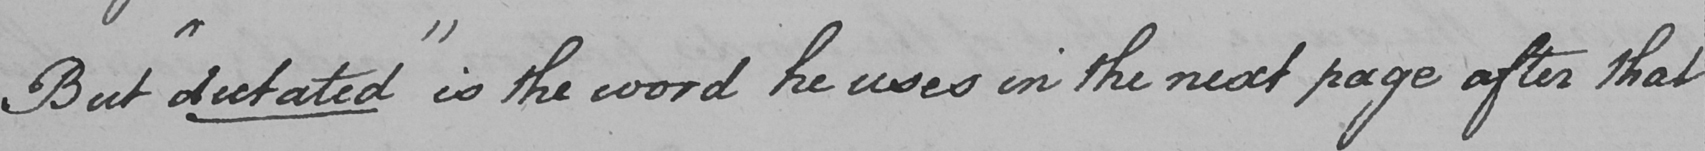What is written in this line of handwriting? But  " dictated "  is the word he uses in the next page after that 